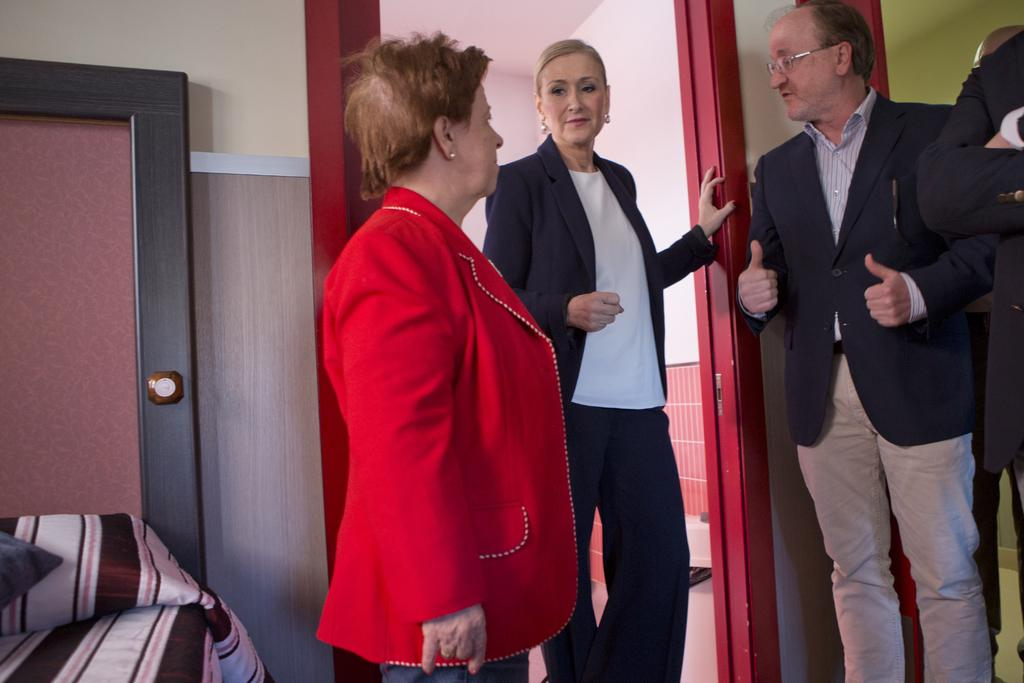What is happening in the image? There are people standing in the image. What type of material is visible in the image? There is cloth visible in the image. Can you describe any architectural features in the image? There is a door in the image, and a wall can be seen in the background. What type of print can be seen on the channel in the image? There is no channel or print present in the image. 